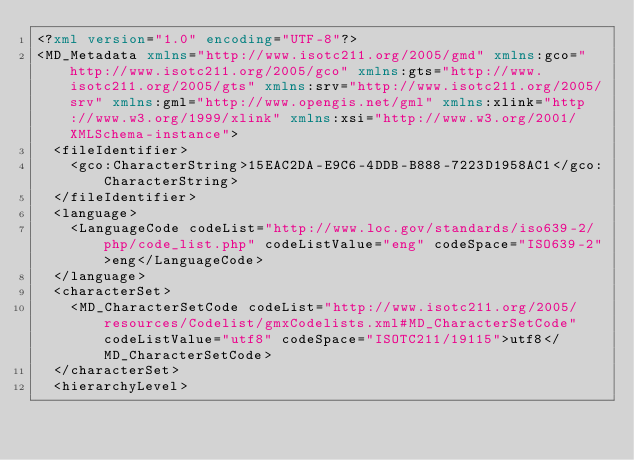Convert code to text. <code><loc_0><loc_0><loc_500><loc_500><_XML_><?xml version="1.0" encoding="UTF-8"?>
<MD_Metadata xmlns="http://www.isotc211.org/2005/gmd" xmlns:gco="http://www.isotc211.org/2005/gco" xmlns:gts="http://www.isotc211.org/2005/gts" xmlns:srv="http://www.isotc211.org/2005/srv" xmlns:gml="http://www.opengis.net/gml" xmlns:xlink="http://www.w3.org/1999/xlink" xmlns:xsi="http://www.w3.org/2001/XMLSchema-instance">
  <fileIdentifier>
    <gco:CharacterString>15EAC2DA-E9C6-4DDB-B888-7223D1958AC1</gco:CharacterString>
  </fileIdentifier>
  <language>
    <LanguageCode codeList="http://www.loc.gov/standards/iso639-2/php/code_list.php" codeListValue="eng" codeSpace="ISO639-2">eng</LanguageCode>
  </language>
  <characterSet>
    <MD_CharacterSetCode codeList="http://www.isotc211.org/2005/resources/Codelist/gmxCodelists.xml#MD_CharacterSetCode" codeListValue="utf8" codeSpace="ISOTC211/19115">utf8</MD_CharacterSetCode>
  </characterSet>
  <hierarchyLevel></code> 